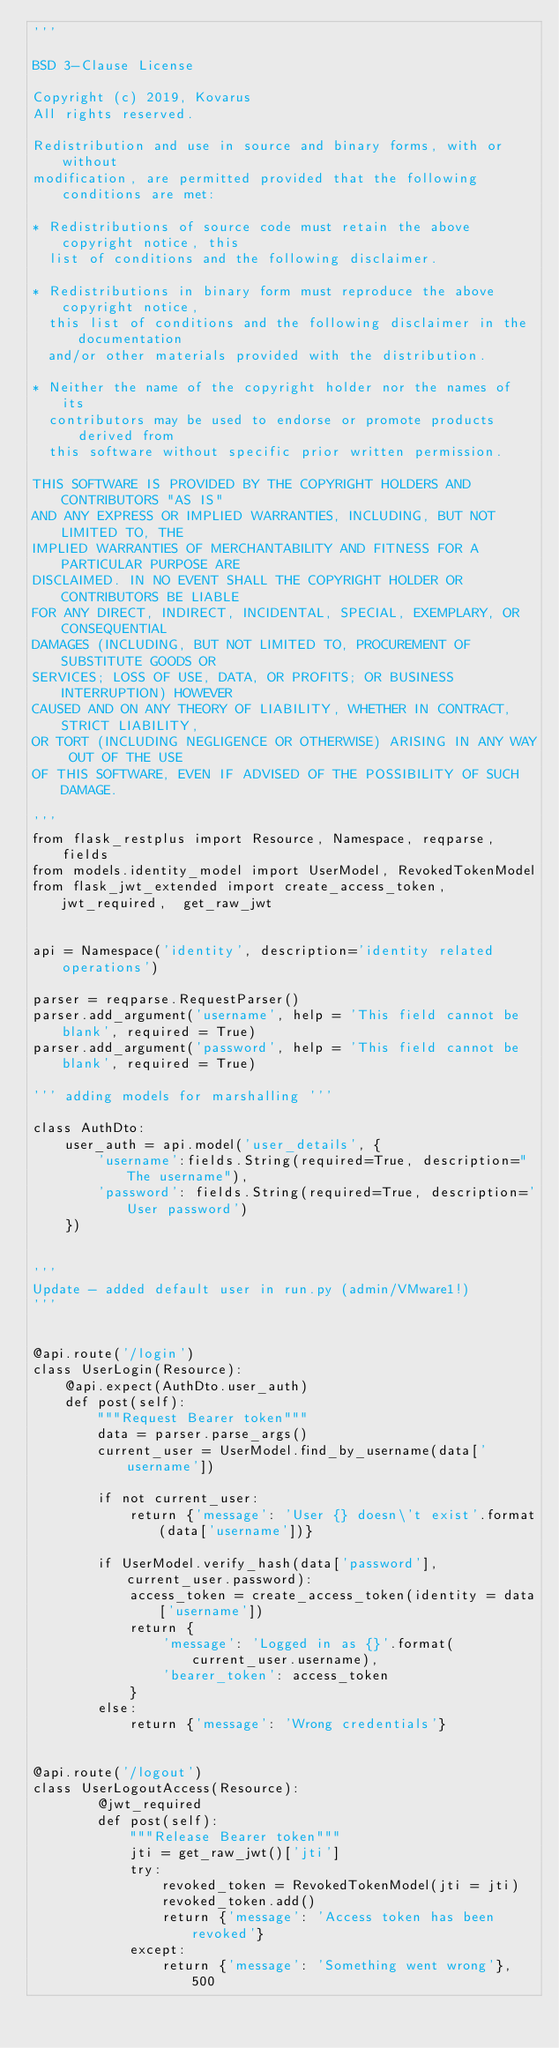<code> <loc_0><loc_0><loc_500><loc_500><_Python_>'''

BSD 3-Clause License

Copyright (c) 2019, Kovarus
All rights reserved.

Redistribution and use in source and binary forms, with or without
modification, are permitted provided that the following conditions are met:

* Redistributions of source code must retain the above copyright notice, this
  list of conditions and the following disclaimer.

* Redistributions in binary form must reproduce the above copyright notice,
  this list of conditions and the following disclaimer in the documentation
  and/or other materials provided with the distribution.

* Neither the name of the copyright holder nor the names of its
  contributors may be used to endorse or promote products derived from
  this software without specific prior written permission.

THIS SOFTWARE IS PROVIDED BY THE COPYRIGHT HOLDERS AND CONTRIBUTORS "AS IS"
AND ANY EXPRESS OR IMPLIED WARRANTIES, INCLUDING, BUT NOT LIMITED TO, THE
IMPLIED WARRANTIES OF MERCHANTABILITY AND FITNESS FOR A PARTICULAR PURPOSE ARE
DISCLAIMED. IN NO EVENT SHALL THE COPYRIGHT HOLDER OR CONTRIBUTORS BE LIABLE
FOR ANY DIRECT, INDIRECT, INCIDENTAL, SPECIAL, EXEMPLARY, OR CONSEQUENTIAL
DAMAGES (INCLUDING, BUT NOT LIMITED TO, PROCUREMENT OF SUBSTITUTE GOODS OR
SERVICES; LOSS OF USE, DATA, OR PROFITS; OR BUSINESS INTERRUPTION) HOWEVER
CAUSED AND ON ANY THEORY OF LIABILITY, WHETHER IN CONTRACT, STRICT LIABILITY,
OR TORT (INCLUDING NEGLIGENCE OR OTHERWISE) ARISING IN ANY WAY OUT OF THE USE
OF THIS SOFTWARE, EVEN IF ADVISED OF THE POSSIBILITY OF SUCH DAMAGE.

'''
from flask_restplus import Resource, Namespace, reqparse, fields
from models.identity_model import UserModel, RevokedTokenModel
from flask_jwt_extended import create_access_token, jwt_required,  get_raw_jwt


api = Namespace('identity', description='identity related operations')

parser = reqparse.RequestParser()
parser.add_argument('username', help = 'This field cannot be blank', required = True)
parser.add_argument('password', help = 'This field cannot be blank', required = True)

''' adding models for marshalling '''

class AuthDto:
    user_auth = api.model('user_details', {
        'username':fields.String(required=True, description="The username"),
        'password': fields.String(required=True, description='User password')
    })


''' 
Update - added default user in run.py (admin/VMware1!)
'''


@api.route('/login')
class UserLogin(Resource):
    @api.expect(AuthDto.user_auth)
    def post(self):
        """Request Bearer token"""
        data = parser.parse_args()
        current_user = UserModel.find_by_username(data['username'])

        if not current_user:
            return {'message': 'User {} doesn\'t exist'.format(data['username'])}

        if UserModel.verify_hash(data['password'], current_user.password):
            access_token = create_access_token(identity = data['username'])
            return {
                'message': 'Logged in as {}'.format(current_user.username),
                'bearer_token': access_token
            }
        else:
            return {'message': 'Wrong credentials'}


@api.route('/logout')
class UserLogoutAccess(Resource):
        @jwt_required
        def post(self):
            """Release Bearer token"""
            jti = get_raw_jwt()['jti']
            try:
                revoked_token = RevokedTokenModel(jti = jti)
                revoked_token.add()
                return {'message': 'Access token has been revoked'}
            except:
                return {'message': 'Something went wrong'}, 500


</code> 